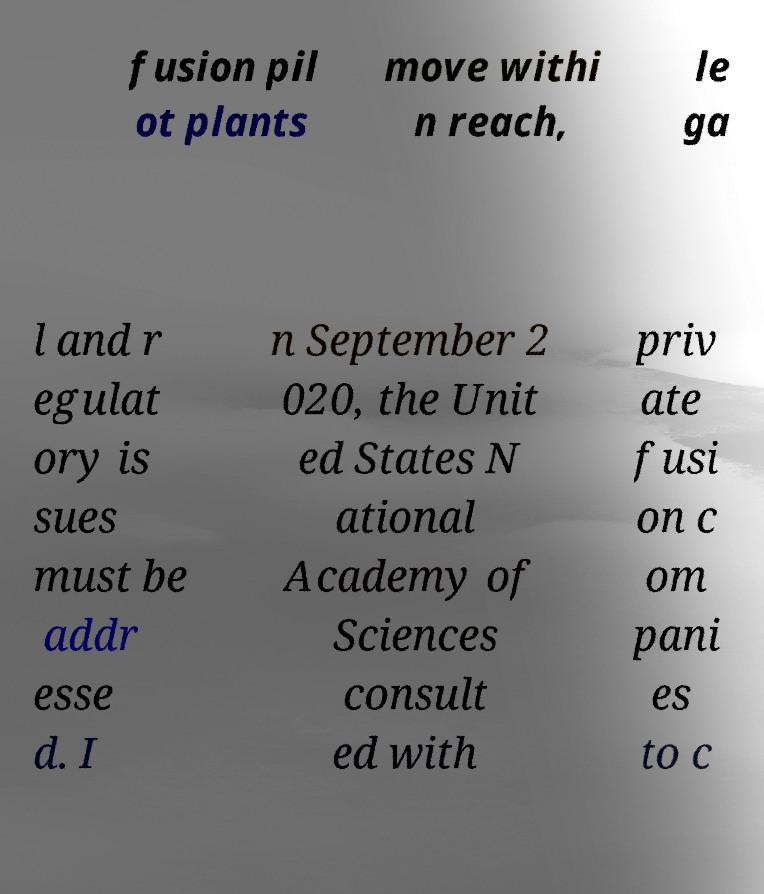Please identify and transcribe the text found in this image. fusion pil ot plants move withi n reach, le ga l and r egulat ory is sues must be addr esse d. I n September 2 020, the Unit ed States N ational Academy of Sciences consult ed with priv ate fusi on c om pani es to c 